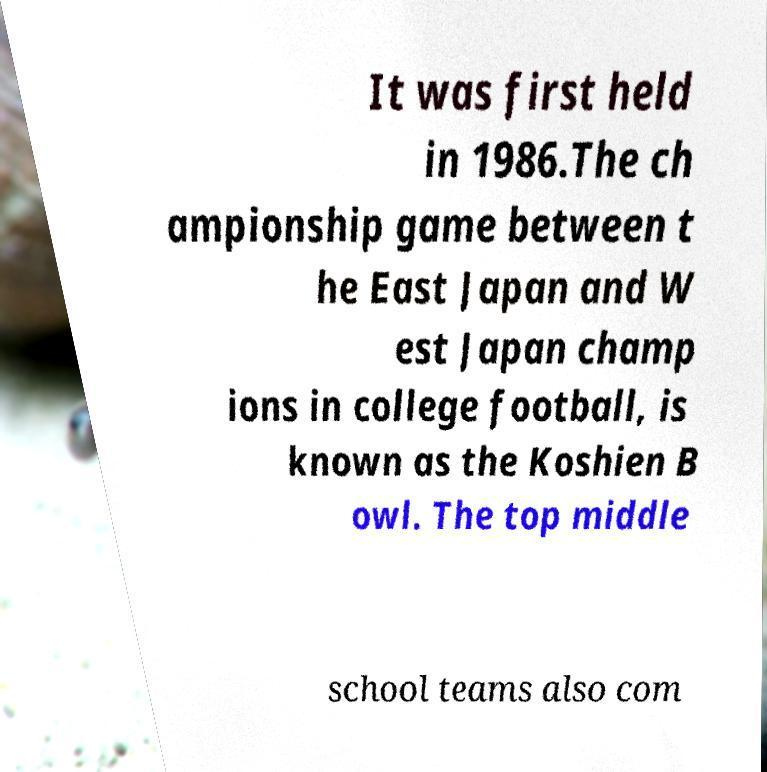Could you assist in decoding the text presented in this image and type it out clearly? It was first held in 1986.The ch ampionship game between t he East Japan and W est Japan champ ions in college football, is known as the Koshien B owl. The top middle school teams also com 